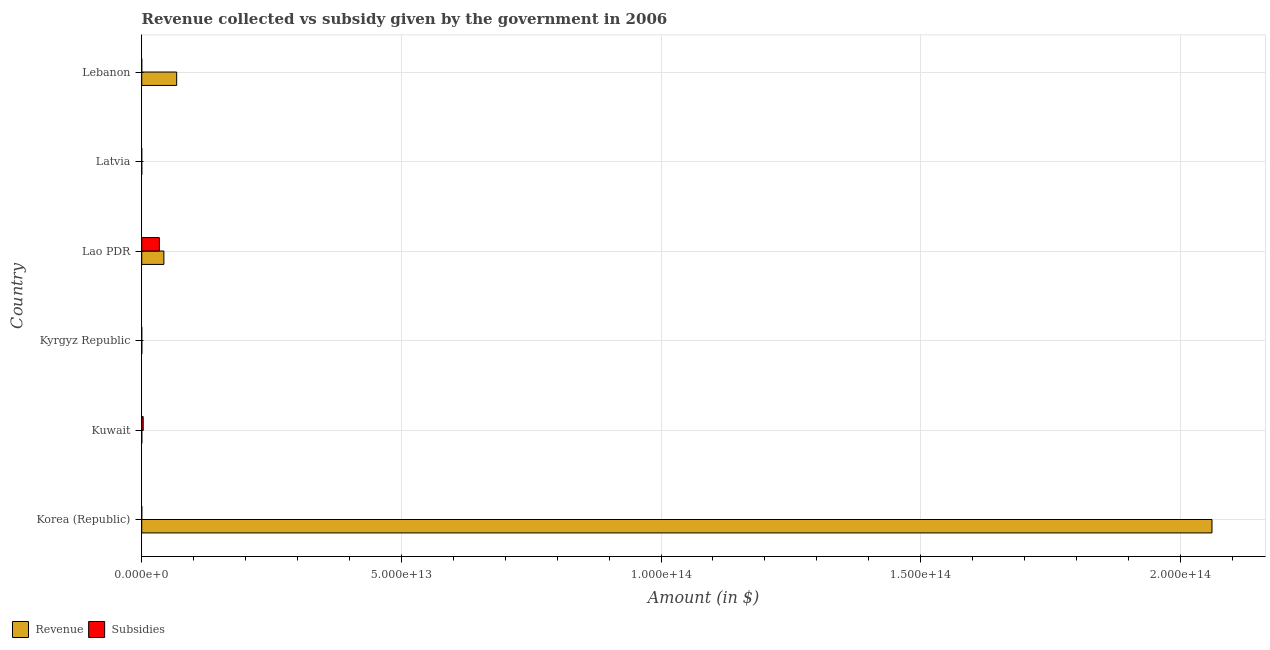How many groups of bars are there?
Your response must be concise. 6. Are the number of bars per tick equal to the number of legend labels?
Your response must be concise. Yes. Are the number of bars on each tick of the Y-axis equal?
Your answer should be compact. Yes. How many bars are there on the 5th tick from the top?
Your response must be concise. 2. In how many cases, is the number of bars for a given country not equal to the number of legend labels?
Your answer should be compact. 0. What is the amount of revenue collected in Kyrgyz Republic?
Give a very brief answer. 1.87e+1. Across all countries, what is the maximum amount of revenue collected?
Provide a short and direct response. 2.06e+14. Across all countries, what is the minimum amount of revenue collected?
Give a very brief answer. 3.04e+09. In which country was the amount of subsidies given maximum?
Offer a terse response. Lao PDR. In which country was the amount of revenue collected minimum?
Your response must be concise. Latvia. What is the total amount of revenue collected in the graph?
Your response must be concise. 2.17e+14. What is the difference between the amount of revenue collected in Korea (Republic) and that in Kuwait?
Keep it short and to the point. 2.06e+14. What is the difference between the amount of revenue collected in Kyrgyz Republic and the amount of subsidies given in Kuwait?
Offer a terse response. -2.68e+11. What is the average amount of revenue collected per country?
Offer a terse response. 3.62e+13. What is the difference between the amount of subsidies given and amount of revenue collected in Korea (Republic)?
Make the answer very short. -2.06e+14. What is the ratio of the amount of subsidies given in Korea (Republic) to that in Kyrgyz Republic?
Offer a very short reply. 5.42. Is the difference between the amount of revenue collected in Korea (Republic) and Kyrgyz Republic greater than the difference between the amount of subsidies given in Korea (Republic) and Kyrgyz Republic?
Your response must be concise. Yes. What is the difference between the highest and the second highest amount of subsidies given?
Give a very brief answer. 3.11e+12. What is the difference between the highest and the lowest amount of subsidies given?
Provide a short and direct response. 3.40e+12. Is the sum of the amount of revenue collected in Kyrgyz Republic and Lebanon greater than the maximum amount of subsidies given across all countries?
Your response must be concise. Yes. What does the 1st bar from the top in Latvia represents?
Give a very brief answer. Subsidies. What does the 1st bar from the bottom in Latvia represents?
Your answer should be compact. Revenue. How many bars are there?
Provide a succinct answer. 12. Are all the bars in the graph horizontal?
Keep it short and to the point. Yes. How many countries are there in the graph?
Keep it short and to the point. 6. What is the difference between two consecutive major ticks on the X-axis?
Provide a short and direct response. 5.00e+13. Are the values on the major ticks of X-axis written in scientific E-notation?
Offer a very short reply. Yes. Does the graph contain grids?
Your answer should be compact. Yes. Where does the legend appear in the graph?
Offer a terse response. Bottom left. How many legend labels are there?
Provide a short and direct response. 2. What is the title of the graph?
Offer a very short reply. Revenue collected vs subsidy given by the government in 2006. Does "Male population" appear as one of the legend labels in the graph?
Offer a very short reply. No. What is the label or title of the X-axis?
Ensure brevity in your answer.  Amount (in $). What is the label or title of the Y-axis?
Provide a succinct answer. Country. What is the Amount (in $) of Revenue in Korea (Republic)?
Keep it short and to the point. 2.06e+14. What is the Amount (in $) of Subsidies in Korea (Republic)?
Give a very brief answer. 6.97e+09. What is the Amount (in $) of Revenue in Kuwait?
Offer a very short reply. 1.53e+1. What is the Amount (in $) in Subsidies in Kuwait?
Make the answer very short. 2.87e+11. What is the Amount (in $) in Revenue in Kyrgyz Republic?
Your response must be concise. 1.87e+1. What is the Amount (in $) in Subsidies in Kyrgyz Republic?
Your response must be concise. 1.28e+09. What is the Amount (in $) in Revenue in Lao PDR?
Keep it short and to the point. 4.27e+12. What is the Amount (in $) of Subsidies in Lao PDR?
Your answer should be very brief. 3.40e+12. What is the Amount (in $) of Revenue in Latvia?
Your response must be concise. 3.04e+09. What is the Amount (in $) of Subsidies in Latvia?
Provide a short and direct response. 6.32e+08. What is the Amount (in $) of Revenue in Lebanon?
Your answer should be compact. 6.73e+12. What is the Amount (in $) of Subsidies in Lebanon?
Keep it short and to the point. 1.65e+05. Across all countries, what is the maximum Amount (in $) in Revenue?
Give a very brief answer. 2.06e+14. Across all countries, what is the maximum Amount (in $) in Subsidies?
Keep it short and to the point. 3.40e+12. Across all countries, what is the minimum Amount (in $) in Revenue?
Give a very brief answer. 3.04e+09. Across all countries, what is the minimum Amount (in $) of Subsidies?
Your answer should be very brief. 1.65e+05. What is the total Amount (in $) in Revenue in the graph?
Your answer should be very brief. 2.17e+14. What is the total Amount (in $) in Subsidies in the graph?
Provide a short and direct response. 3.69e+12. What is the difference between the Amount (in $) in Revenue in Korea (Republic) and that in Kuwait?
Your answer should be very brief. 2.06e+14. What is the difference between the Amount (in $) in Subsidies in Korea (Republic) and that in Kuwait?
Offer a terse response. -2.80e+11. What is the difference between the Amount (in $) in Revenue in Korea (Republic) and that in Kyrgyz Republic?
Give a very brief answer. 2.06e+14. What is the difference between the Amount (in $) of Subsidies in Korea (Republic) and that in Kyrgyz Republic?
Your answer should be compact. 5.68e+09. What is the difference between the Amount (in $) in Revenue in Korea (Republic) and that in Lao PDR?
Provide a short and direct response. 2.02e+14. What is the difference between the Amount (in $) of Subsidies in Korea (Republic) and that in Lao PDR?
Your response must be concise. -3.39e+12. What is the difference between the Amount (in $) in Revenue in Korea (Republic) and that in Latvia?
Offer a very short reply. 2.06e+14. What is the difference between the Amount (in $) of Subsidies in Korea (Republic) and that in Latvia?
Keep it short and to the point. 6.33e+09. What is the difference between the Amount (in $) of Revenue in Korea (Republic) and that in Lebanon?
Your answer should be very brief. 1.99e+14. What is the difference between the Amount (in $) of Subsidies in Korea (Republic) and that in Lebanon?
Your answer should be very brief. 6.97e+09. What is the difference between the Amount (in $) in Revenue in Kuwait and that in Kyrgyz Republic?
Offer a very short reply. -3.44e+09. What is the difference between the Amount (in $) in Subsidies in Kuwait and that in Kyrgyz Republic?
Provide a short and direct response. 2.85e+11. What is the difference between the Amount (in $) of Revenue in Kuwait and that in Lao PDR?
Provide a short and direct response. -4.25e+12. What is the difference between the Amount (in $) in Subsidies in Kuwait and that in Lao PDR?
Your answer should be compact. -3.11e+12. What is the difference between the Amount (in $) of Revenue in Kuwait and that in Latvia?
Your answer should be compact. 1.23e+1. What is the difference between the Amount (in $) of Subsidies in Kuwait and that in Latvia?
Your response must be concise. 2.86e+11. What is the difference between the Amount (in $) in Revenue in Kuwait and that in Lebanon?
Provide a short and direct response. -6.71e+12. What is the difference between the Amount (in $) of Subsidies in Kuwait and that in Lebanon?
Ensure brevity in your answer.  2.87e+11. What is the difference between the Amount (in $) of Revenue in Kyrgyz Republic and that in Lao PDR?
Give a very brief answer. -4.25e+12. What is the difference between the Amount (in $) of Subsidies in Kyrgyz Republic and that in Lao PDR?
Make the answer very short. -3.40e+12. What is the difference between the Amount (in $) in Revenue in Kyrgyz Republic and that in Latvia?
Your answer should be compact. 1.57e+1. What is the difference between the Amount (in $) in Subsidies in Kyrgyz Republic and that in Latvia?
Keep it short and to the point. 6.53e+08. What is the difference between the Amount (in $) in Revenue in Kyrgyz Republic and that in Lebanon?
Offer a very short reply. -6.71e+12. What is the difference between the Amount (in $) in Subsidies in Kyrgyz Republic and that in Lebanon?
Offer a terse response. 1.28e+09. What is the difference between the Amount (in $) of Revenue in Lao PDR and that in Latvia?
Your answer should be compact. 4.26e+12. What is the difference between the Amount (in $) of Subsidies in Lao PDR and that in Latvia?
Make the answer very short. 3.40e+12. What is the difference between the Amount (in $) of Revenue in Lao PDR and that in Lebanon?
Give a very brief answer. -2.46e+12. What is the difference between the Amount (in $) in Subsidies in Lao PDR and that in Lebanon?
Offer a very short reply. 3.40e+12. What is the difference between the Amount (in $) in Revenue in Latvia and that in Lebanon?
Offer a very short reply. -6.73e+12. What is the difference between the Amount (in $) in Subsidies in Latvia and that in Lebanon?
Ensure brevity in your answer.  6.32e+08. What is the difference between the Amount (in $) in Revenue in Korea (Republic) and the Amount (in $) in Subsidies in Kuwait?
Your answer should be compact. 2.06e+14. What is the difference between the Amount (in $) of Revenue in Korea (Republic) and the Amount (in $) of Subsidies in Kyrgyz Republic?
Offer a terse response. 2.06e+14. What is the difference between the Amount (in $) of Revenue in Korea (Republic) and the Amount (in $) of Subsidies in Lao PDR?
Your answer should be very brief. 2.03e+14. What is the difference between the Amount (in $) of Revenue in Korea (Republic) and the Amount (in $) of Subsidies in Latvia?
Provide a succinct answer. 2.06e+14. What is the difference between the Amount (in $) of Revenue in Korea (Republic) and the Amount (in $) of Subsidies in Lebanon?
Ensure brevity in your answer.  2.06e+14. What is the difference between the Amount (in $) of Revenue in Kuwait and the Amount (in $) of Subsidies in Kyrgyz Republic?
Make the answer very short. 1.40e+1. What is the difference between the Amount (in $) in Revenue in Kuwait and the Amount (in $) in Subsidies in Lao PDR?
Your response must be concise. -3.38e+12. What is the difference between the Amount (in $) in Revenue in Kuwait and the Amount (in $) in Subsidies in Latvia?
Ensure brevity in your answer.  1.47e+1. What is the difference between the Amount (in $) in Revenue in Kuwait and the Amount (in $) in Subsidies in Lebanon?
Give a very brief answer. 1.53e+1. What is the difference between the Amount (in $) in Revenue in Kyrgyz Republic and the Amount (in $) in Subsidies in Lao PDR?
Ensure brevity in your answer.  -3.38e+12. What is the difference between the Amount (in $) of Revenue in Kyrgyz Republic and the Amount (in $) of Subsidies in Latvia?
Ensure brevity in your answer.  1.81e+1. What is the difference between the Amount (in $) of Revenue in Kyrgyz Republic and the Amount (in $) of Subsidies in Lebanon?
Your response must be concise. 1.87e+1. What is the difference between the Amount (in $) in Revenue in Lao PDR and the Amount (in $) in Subsidies in Latvia?
Your answer should be compact. 4.27e+12. What is the difference between the Amount (in $) in Revenue in Lao PDR and the Amount (in $) in Subsidies in Lebanon?
Make the answer very short. 4.27e+12. What is the difference between the Amount (in $) of Revenue in Latvia and the Amount (in $) of Subsidies in Lebanon?
Provide a short and direct response. 3.04e+09. What is the average Amount (in $) in Revenue per country?
Provide a succinct answer. 3.62e+13. What is the average Amount (in $) of Subsidies per country?
Provide a succinct answer. 6.15e+11. What is the difference between the Amount (in $) of Revenue and Amount (in $) of Subsidies in Korea (Republic)?
Ensure brevity in your answer.  2.06e+14. What is the difference between the Amount (in $) in Revenue and Amount (in $) in Subsidies in Kuwait?
Offer a terse response. -2.71e+11. What is the difference between the Amount (in $) of Revenue and Amount (in $) of Subsidies in Kyrgyz Republic?
Provide a succinct answer. 1.75e+1. What is the difference between the Amount (in $) of Revenue and Amount (in $) of Subsidies in Lao PDR?
Provide a succinct answer. 8.69e+11. What is the difference between the Amount (in $) of Revenue and Amount (in $) of Subsidies in Latvia?
Make the answer very short. 2.41e+09. What is the difference between the Amount (in $) of Revenue and Amount (in $) of Subsidies in Lebanon?
Offer a very short reply. 6.73e+12. What is the ratio of the Amount (in $) in Revenue in Korea (Republic) to that in Kuwait?
Your answer should be very brief. 1.35e+04. What is the ratio of the Amount (in $) of Subsidies in Korea (Republic) to that in Kuwait?
Offer a terse response. 0.02. What is the ratio of the Amount (in $) in Revenue in Korea (Republic) to that in Kyrgyz Republic?
Provide a succinct answer. 1.10e+04. What is the ratio of the Amount (in $) of Subsidies in Korea (Republic) to that in Kyrgyz Republic?
Make the answer very short. 5.42. What is the ratio of the Amount (in $) of Revenue in Korea (Republic) to that in Lao PDR?
Make the answer very short. 48.31. What is the ratio of the Amount (in $) of Subsidies in Korea (Republic) to that in Lao PDR?
Offer a very short reply. 0. What is the ratio of the Amount (in $) in Revenue in Korea (Republic) to that in Latvia?
Your response must be concise. 6.78e+04. What is the ratio of the Amount (in $) in Subsidies in Korea (Republic) to that in Latvia?
Your answer should be compact. 11.03. What is the ratio of the Amount (in $) of Revenue in Korea (Republic) to that in Lebanon?
Ensure brevity in your answer.  30.62. What is the ratio of the Amount (in $) in Subsidies in Korea (Republic) to that in Lebanon?
Ensure brevity in your answer.  4.23e+04. What is the ratio of the Amount (in $) of Revenue in Kuwait to that in Kyrgyz Republic?
Provide a succinct answer. 0.82. What is the ratio of the Amount (in $) in Subsidies in Kuwait to that in Kyrgyz Republic?
Your answer should be very brief. 223.01. What is the ratio of the Amount (in $) of Revenue in Kuwait to that in Lao PDR?
Your response must be concise. 0. What is the ratio of the Amount (in $) of Subsidies in Kuwait to that in Lao PDR?
Make the answer very short. 0.08. What is the ratio of the Amount (in $) in Revenue in Kuwait to that in Latvia?
Provide a short and direct response. 5.04. What is the ratio of the Amount (in $) of Subsidies in Kuwait to that in Latvia?
Offer a very short reply. 453.48. What is the ratio of the Amount (in $) of Revenue in Kuwait to that in Lebanon?
Your response must be concise. 0. What is the ratio of the Amount (in $) of Subsidies in Kuwait to that in Lebanon?
Provide a succinct answer. 1.74e+06. What is the ratio of the Amount (in $) of Revenue in Kyrgyz Republic to that in Lao PDR?
Your response must be concise. 0. What is the ratio of the Amount (in $) of Revenue in Kyrgyz Republic to that in Latvia?
Keep it short and to the point. 6.17. What is the ratio of the Amount (in $) of Subsidies in Kyrgyz Republic to that in Latvia?
Provide a succinct answer. 2.03. What is the ratio of the Amount (in $) of Revenue in Kyrgyz Republic to that in Lebanon?
Give a very brief answer. 0. What is the ratio of the Amount (in $) in Subsidies in Kyrgyz Republic to that in Lebanon?
Keep it short and to the point. 7802.33. What is the ratio of the Amount (in $) in Revenue in Lao PDR to that in Latvia?
Give a very brief answer. 1404.12. What is the ratio of the Amount (in $) of Subsidies in Lao PDR to that in Latvia?
Your response must be concise. 5376.17. What is the ratio of the Amount (in $) in Revenue in Lao PDR to that in Lebanon?
Give a very brief answer. 0.63. What is the ratio of the Amount (in $) in Subsidies in Lao PDR to that in Lebanon?
Your answer should be compact. 2.06e+07. What is the ratio of the Amount (in $) of Subsidies in Latvia to that in Lebanon?
Ensure brevity in your answer.  3837.05. What is the difference between the highest and the second highest Amount (in $) in Revenue?
Provide a short and direct response. 1.99e+14. What is the difference between the highest and the second highest Amount (in $) in Subsidies?
Keep it short and to the point. 3.11e+12. What is the difference between the highest and the lowest Amount (in $) in Revenue?
Keep it short and to the point. 2.06e+14. What is the difference between the highest and the lowest Amount (in $) in Subsidies?
Your response must be concise. 3.40e+12. 